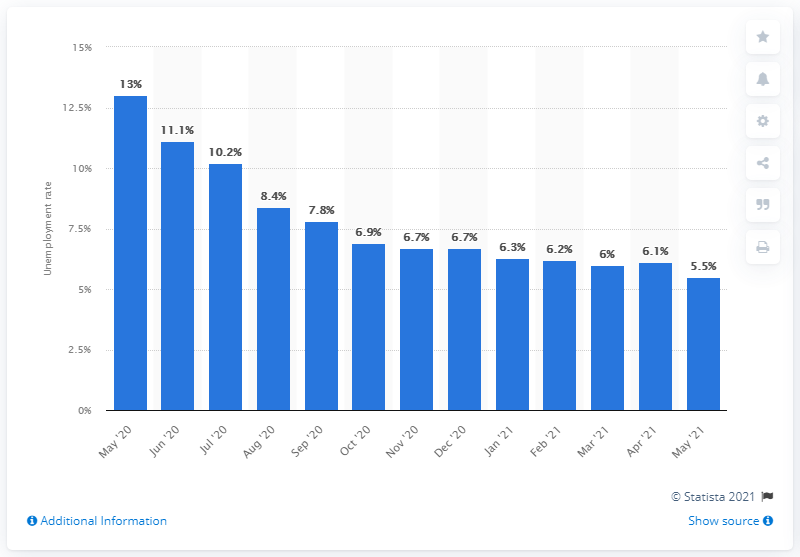List a handful of essential elements in this visual. In May 2021, the national unemployment rate was 5.5%. 